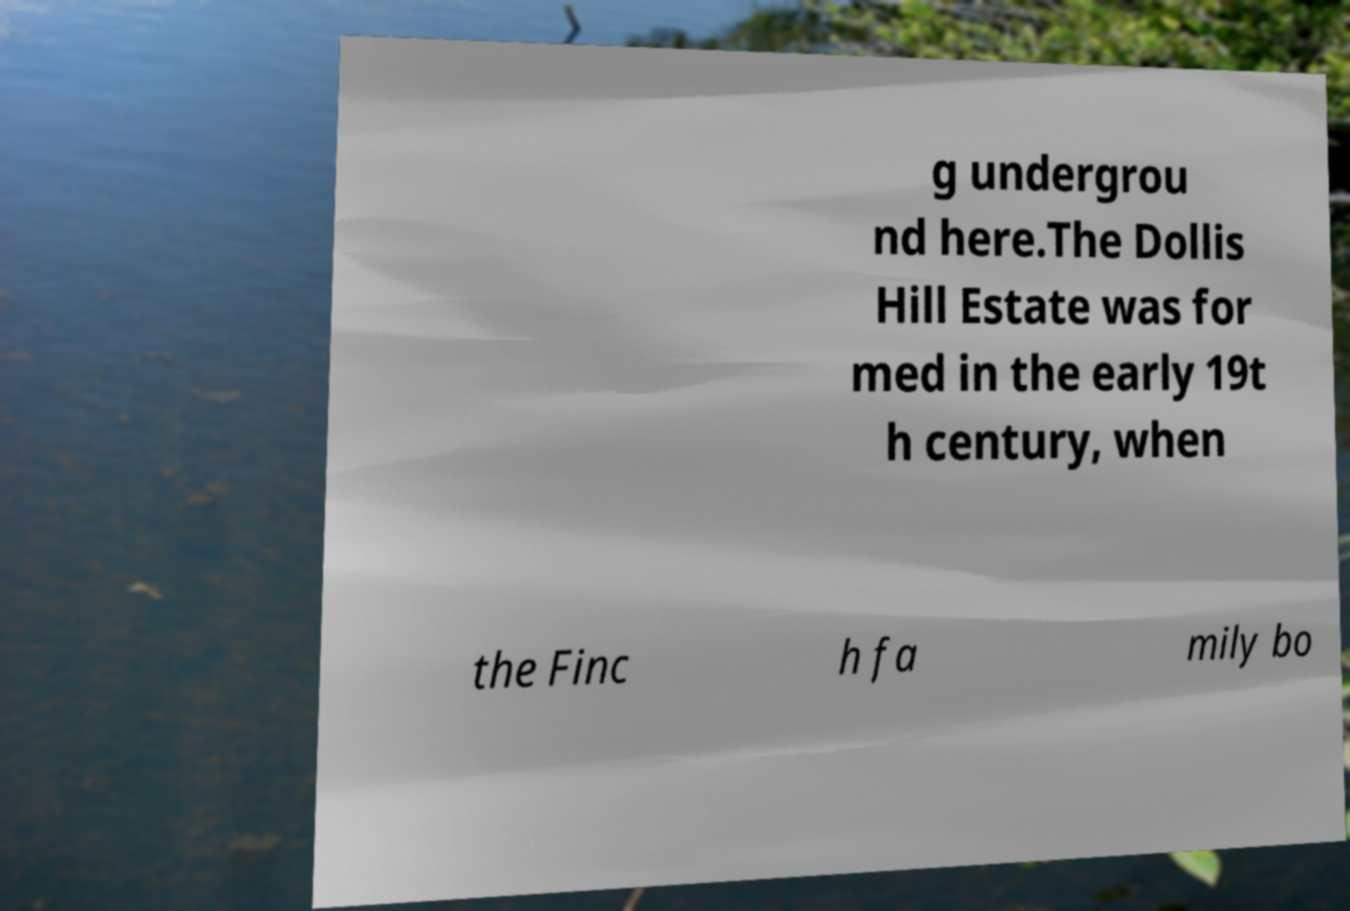Can you accurately transcribe the text from the provided image for me? g undergrou nd here.The Dollis Hill Estate was for med in the early 19t h century, when the Finc h fa mily bo 